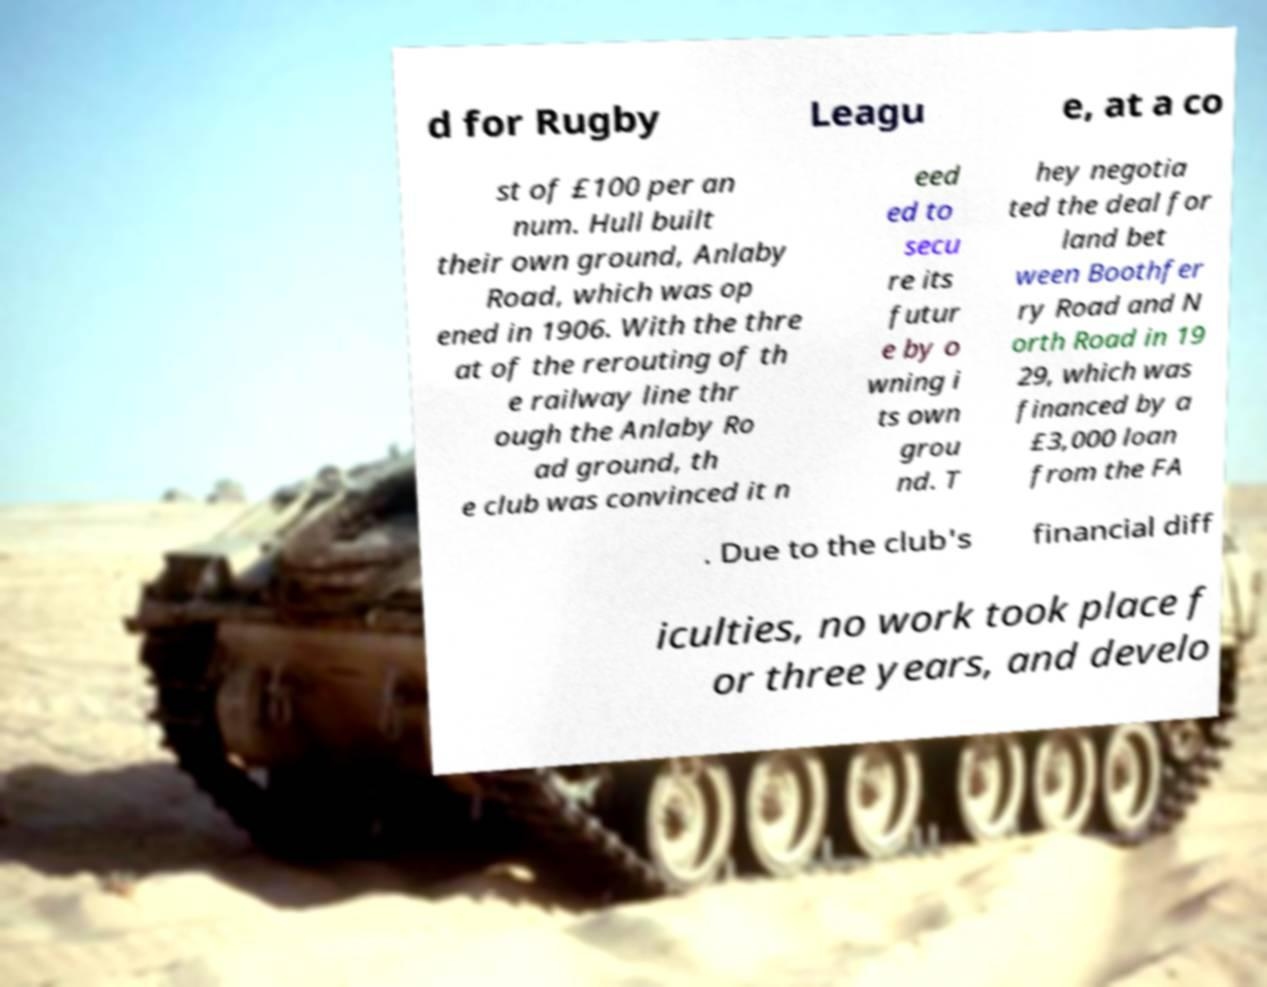For documentation purposes, I need the text within this image transcribed. Could you provide that? d for Rugby Leagu e, at a co st of £100 per an num. Hull built their own ground, Anlaby Road, which was op ened in 1906. With the thre at of the rerouting of th e railway line thr ough the Anlaby Ro ad ground, th e club was convinced it n eed ed to secu re its futur e by o wning i ts own grou nd. T hey negotia ted the deal for land bet ween Boothfer ry Road and N orth Road in 19 29, which was financed by a £3,000 loan from the FA . Due to the club's financial diff iculties, no work took place f or three years, and develo 